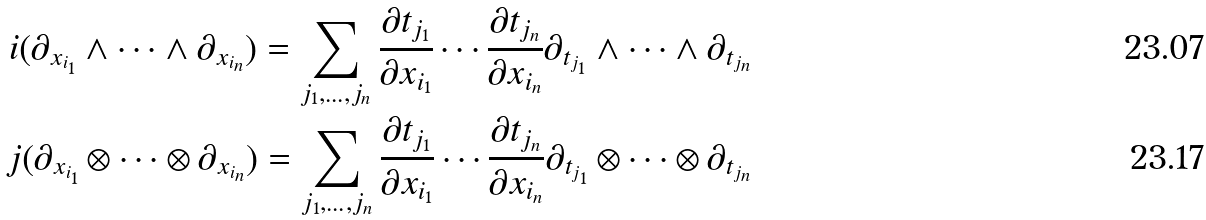<formula> <loc_0><loc_0><loc_500><loc_500>i ( \partial _ { x _ { i _ { 1 } } } \wedge \cdots \wedge \partial _ { x _ { i _ { n } } } ) = \sum _ { j _ { 1 } , \dots , j _ { n } } \frac { \partial t _ { j _ { 1 } } } { \partial x _ { i _ { 1 } } } \cdots \frac { \partial t _ { j _ { n } } } { \partial x _ { i _ { n } } } \partial _ { t _ { j _ { 1 } } } \wedge \cdots \wedge \partial _ { t _ { j _ { n } } } \\ j ( \partial _ { x _ { i _ { 1 } } } \otimes \cdots \otimes \partial _ { x _ { i _ { n } } } ) = \sum _ { j _ { 1 } , \dots , j _ { n } } \frac { \partial t _ { j _ { 1 } } } { \partial x _ { i _ { 1 } } } \cdots \frac { \partial t _ { j _ { n } } } { \partial x _ { i _ { n } } } \partial _ { t _ { j _ { 1 } } } \otimes \cdots \otimes \partial _ { t _ { j _ { n } } }</formula> 